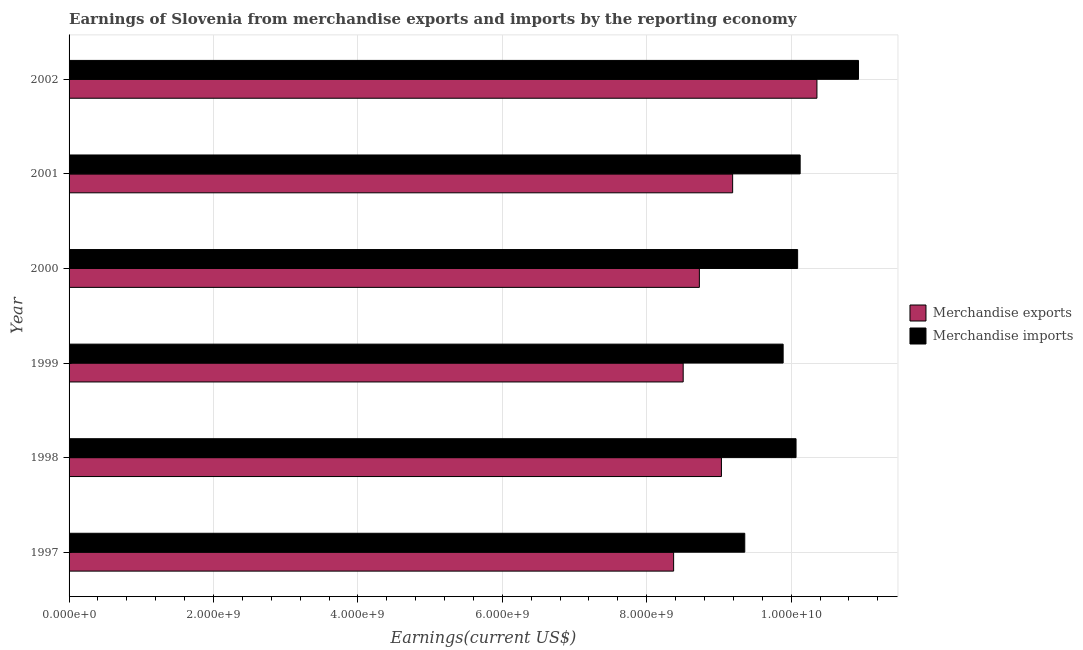How many groups of bars are there?
Give a very brief answer. 6. Are the number of bars per tick equal to the number of legend labels?
Offer a very short reply. Yes. How many bars are there on the 6th tick from the bottom?
Offer a very short reply. 2. In how many cases, is the number of bars for a given year not equal to the number of legend labels?
Keep it short and to the point. 0. What is the earnings from merchandise exports in 1997?
Ensure brevity in your answer.  8.37e+09. Across all years, what is the maximum earnings from merchandise imports?
Your answer should be compact. 1.09e+1. Across all years, what is the minimum earnings from merchandise imports?
Offer a terse response. 9.36e+09. What is the total earnings from merchandise imports in the graph?
Ensure brevity in your answer.  6.05e+1. What is the difference between the earnings from merchandise exports in 1999 and that in 2002?
Offer a very short reply. -1.85e+09. What is the difference between the earnings from merchandise imports in 2002 and the earnings from merchandise exports in 1997?
Offer a terse response. 2.56e+09. What is the average earnings from merchandise imports per year?
Your answer should be very brief. 1.01e+1. In the year 2002, what is the difference between the earnings from merchandise imports and earnings from merchandise exports?
Offer a very short reply. 5.75e+08. In how many years, is the earnings from merchandise imports greater than 1200000000 US$?
Your answer should be very brief. 6. What is the ratio of the earnings from merchandise imports in 2001 to that in 2002?
Offer a very short reply. 0.93. Is the earnings from merchandise exports in 1998 less than that in 2000?
Provide a short and direct response. No. Is the difference between the earnings from merchandise imports in 1997 and 1998 greater than the difference between the earnings from merchandise exports in 1997 and 1998?
Your answer should be compact. No. What is the difference between the highest and the second highest earnings from merchandise imports?
Make the answer very short. 8.08e+08. What is the difference between the highest and the lowest earnings from merchandise exports?
Give a very brief answer. 1.98e+09. Is the sum of the earnings from merchandise imports in 2001 and 2002 greater than the maximum earnings from merchandise exports across all years?
Ensure brevity in your answer.  Yes. What does the 1st bar from the bottom in 1998 represents?
Your answer should be compact. Merchandise exports. Are the values on the major ticks of X-axis written in scientific E-notation?
Your answer should be compact. Yes. Does the graph contain any zero values?
Ensure brevity in your answer.  No. Does the graph contain grids?
Offer a terse response. Yes. Where does the legend appear in the graph?
Your response must be concise. Center right. How many legend labels are there?
Keep it short and to the point. 2. How are the legend labels stacked?
Provide a short and direct response. Vertical. What is the title of the graph?
Your answer should be very brief. Earnings of Slovenia from merchandise exports and imports by the reporting economy. Does "Non-solid fuel" appear as one of the legend labels in the graph?
Ensure brevity in your answer.  No. What is the label or title of the X-axis?
Offer a terse response. Earnings(current US$). What is the Earnings(current US$) in Merchandise exports in 1997?
Give a very brief answer. 8.37e+09. What is the Earnings(current US$) in Merchandise imports in 1997?
Your answer should be compact. 9.36e+09. What is the Earnings(current US$) in Merchandise exports in 1998?
Your response must be concise. 9.03e+09. What is the Earnings(current US$) in Merchandise imports in 1998?
Your response must be concise. 1.01e+1. What is the Earnings(current US$) of Merchandise exports in 1999?
Your response must be concise. 8.50e+09. What is the Earnings(current US$) of Merchandise imports in 1999?
Provide a short and direct response. 9.89e+09. What is the Earnings(current US$) in Merchandise exports in 2000?
Give a very brief answer. 8.73e+09. What is the Earnings(current US$) in Merchandise imports in 2000?
Ensure brevity in your answer.  1.01e+1. What is the Earnings(current US$) in Merchandise exports in 2001?
Ensure brevity in your answer.  9.19e+09. What is the Earnings(current US$) of Merchandise imports in 2001?
Ensure brevity in your answer.  1.01e+1. What is the Earnings(current US$) in Merchandise exports in 2002?
Provide a succinct answer. 1.04e+1. What is the Earnings(current US$) of Merchandise imports in 2002?
Keep it short and to the point. 1.09e+1. Across all years, what is the maximum Earnings(current US$) of Merchandise exports?
Provide a short and direct response. 1.04e+1. Across all years, what is the maximum Earnings(current US$) in Merchandise imports?
Your answer should be very brief. 1.09e+1. Across all years, what is the minimum Earnings(current US$) in Merchandise exports?
Give a very brief answer. 8.37e+09. Across all years, what is the minimum Earnings(current US$) of Merchandise imports?
Your answer should be compact. 9.36e+09. What is the total Earnings(current US$) of Merchandise exports in the graph?
Your response must be concise. 5.42e+1. What is the total Earnings(current US$) of Merchandise imports in the graph?
Provide a short and direct response. 6.05e+1. What is the difference between the Earnings(current US$) of Merchandise exports in 1997 and that in 1998?
Provide a succinct answer. -6.62e+08. What is the difference between the Earnings(current US$) of Merchandise imports in 1997 and that in 1998?
Offer a very short reply. -7.10e+08. What is the difference between the Earnings(current US$) of Merchandise exports in 1997 and that in 1999?
Offer a terse response. -1.33e+08. What is the difference between the Earnings(current US$) of Merchandise imports in 1997 and that in 1999?
Ensure brevity in your answer.  -5.32e+08. What is the difference between the Earnings(current US$) in Merchandise exports in 1997 and that in 2000?
Offer a terse response. -3.57e+08. What is the difference between the Earnings(current US$) of Merchandise imports in 1997 and that in 2000?
Ensure brevity in your answer.  -7.32e+08. What is the difference between the Earnings(current US$) of Merchandise exports in 1997 and that in 2001?
Your response must be concise. -8.17e+08. What is the difference between the Earnings(current US$) in Merchandise imports in 1997 and that in 2001?
Your response must be concise. -7.67e+08. What is the difference between the Earnings(current US$) in Merchandise exports in 1997 and that in 2002?
Your answer should be very brief. -1.98e+09. What is the difference between the Earnings(current US$) of Merchandise imports in 1997 and that in 2002?
Provide a succinct answer. -1.57e+09. What is the difference between the Earnings(current US$) of Merchandise exports in 1998 and that in 1999?
Provide a succinct answer. 5.30e+08. What is the difference between the Earnings(current US$) in Merchandise imports in 1998 and that in 1999?
Your response must be concise. 1.79e+08. What is the difference between the Earnings(current US$) of Merchandise exports in 1998 and that in 2000?
Give a very brief answer. 3.06e+08. What is the difference between the Earnings(current US$) in Merchandise imports in 1998 and that in 2000?
Offer a terse response. -2.18e+07. What is the difference between the Earnings(current US$) of Merchandise exports in 1998 and that in 2001?
Offer a very short reply. -1.55e+08. What is the difference between the Earnings(current US$) of Merchandise imports in 1998 and that in 2001?
Provide a succinct answer. -5.69e+07. What is the difference between the Earnings(current US$) in Merchandise exports in 1998 and that in 2002?
Give a very brief answer. -1.32e+09. What is the difference between the Earnings(current US$) of Merchandise imports in 1998 and that in 2002?
Offer a very short reply. -8.65e+08. What is the difference between the Earnings(current US$) of Merchandise exports in 1999 and that in 2000?
Ensure brevity in your answer.  -2.24e+08. What is the difference between the Earnings(current US$) in Merchandise imports in 1999 and that in 2000?
Ensure brevity in your answer.  -2.00e+08. What is the difference between the Earnings(current US$) in Merchandise exports in 1999 and that in 2001?
Offer a very short reply. -6.85e+08. What is the difference between the Earnings(current US$) in Merchandise imports in 1999 and that in 2001?
Your response must be concise. -2.36e+08. What is the difference between the Earnings(current US$) in Merchandise exports in 1999 and that in 2002?
Keep it short and to the point. -1.85e+09. What is the difference between the Earnings(current US$) in Merchandise imports in 1999 and that in 2002?
Your answer should be very brief. -1.04e+09. What is the difference between the Earnings(current US$) in Merchandise exports in 2000 and that in 2001?
Ensure brevity in your answer.  -4.61e+08. What is the difference between the Earnings(current US$) in Merchandise imports in 2000 and that in 2001?
Keep it short and to the point. -3.51e+07. What is the difference between the Earnings(current US$) in Merchandise exports in 2000 and that in 2002?
Ensure brevity in your answer.  -1.63e+09. What is the difference between the Earnings(current US$) in Merchandise imports in 2000 and that in 2002?
Ensure brevity in your answer.  -8.43e+08. What is the difference between the Earnings(current US$) of Merchandise exports in 2001 and that in 2002?
Make the answer very short. -1.17e+09. What is the difference between the Earnings(current US$) of Merchandise imports in 2001 and that in 2002?
Give a very brief answer. -8.08e+08. What is the difference between the Earnings(current US$) of Merchandise exports in 1997 and the Earnings(current US$) of Merchandise imports in 1998?
Ensure brevity in your answer.  -1.70e+09. What is the difference between the Earnings(current US$) of Merchandise exports in 1997 and the Earnings(current US$) of Merchandise imports in 1999?
Your answer should be compact. -1.52e+09. What is the difference between the Earnings(current US$) in Merchandise exports in 1997 and the Earnings(current US$) in Merchandise imports in 2000?
Keep it short and to the point. -1.72e+09. What is the difference between the Earnings(current US$) in Merchandise exports in 1997 and the Earnings(current US$) in Merchandise imports in 2001?
Your answer should be very brief. -1.75e+09. What is the difference between the Earnings(current US$) of Merchandise exports in 1997 and the Earnings(current US$) of Merchandise imports in 2002?
Keep it short and to the point. -2.56e+09. What is the difference between the Earnings(current US$) of Merchandise exports in 1998 and the Earnings(current US$) of Merchandise imports in 1999?
Offer a very short reply. -8.55e+08. What is the difference between the Earnings(current US$) in Merchandise exports in 1998 and the Earnings(current US$) in Merchandise imports in 2000?
Keep it short and to the point. -1.06e+09. What is the difference between the Earnings(current US$) of Merchandise exports in 1998 and the Earnings(current US$) of Merchandise imports in 2001?
Keep it short and to the point. -1.09e+09. What is the difference between the Earnings(current US$) in Merchandise exports in 1998 and the Earnings(current US$) in Merchandise imports in 2002?
Offer a terse response. -1.90e+09. What is the difference between the Earnings(current US$) of Merchandise exports in 1999 and the Earnings(current US$) of Merchandise imports in 2000?
Offer a very short reply. -1.58e+09. What is the difference between the Earnings(current US$) in Merchandise exports in 1999 and the Earnings(current US$) in Merchandise imports in 2001?
Provide a succinct answer. -1.62e+09. What is the difference between the Earnings(current US$) in Merchandise exports in 1999 and the Earnings(current US$) in Merchandise imports in 2002?
Your response must be concise. -2.43e+09. What is the difference between the Earnings(current US$) of Merchandise exports in 2000 and the Earnings(current US$) of Merchandise imports in 2001?
Make the answer very short. -1.40e+09. What is the difference between the Earnings(current US$) of Merchandise exports in 2000 and the Earnings(current US$) of Merchandise imports in 2002?
Your answer should be very brief. -2.20e+09. What is the difference between the Earnings(current US$) of Merchandise exports in 2001 and the Earnings(current US$) of Merchandise imports in 2002?
Your answer should be compact. -1.74e+09. What is the average Earnings(current US$) in Merchandise exports per year?
Ensure brevity in your answer.  9.03e+09. What is the average Earnings(current US$) in Merchandise imports per year?
Provide a short and direct response. 1.01e+1. In the year 1997, what is the difference between the Earnings(current US$) of Merchandise exports and Earnings(current US$) of Merchandise imports?
Give a very brief answer. -9.85e+08. In the year 1998, what is the difference between the Earnings(current US$) of Merchandise exports and Earnings(current US$) of Merchandise imports?
Give a very brief answer. -1.03e+09. In the year 1999, what is the difference between the Earnings(current US$) of Merchandise exports and Earnings(current US$) of Merchandise imports?
Provide a succinct answer. -1.38e+09. In the year 2000, what is the difference between the Earnings(current US$) of Merchandise exports and Earnings(current US$) of Merchandise imports?
Your response must be concise. -1.36e+09. In the year 2001, what is the difference between the Earnings(current US$) of Merchandise exports and Earnings(current US$) of Merchandise imports?
Provide a short and direct response. -9.35e+08. In the year 2002, what is the difference between the Earnings(current US$) of Merchandise exports and Earnings(current US$) of Merchandise imports?
Give a very brief answer. -5.75e+08. What is the ratio of the Earnings(current US$) of Merchandise exports in 1997 to that in 1998?
Offer a terse response. 0.93. What is the ratio of the Earnings(current US$) in Merchandise imports in 1997 to that in 1998?
Make the answer very short. 0.93. What is the ratio of the Earnings(current US$) in Merchandise exports in 1997 to that in 1999?
Offer a terse response. 0.98. What is the ratio of the Earnings(current US$) in Merchandise imports in 1997 to that in 1999?
Offer a very short reply. 0.95. What is the ratio of the Earnings(current US$) of Merchandise exports in 1997 to that in 2000?
Make the answer very short. 0.96. What is the ratio of the Earnings(current US$) in Merchandise imports in 1997 to that in 2000?
Offer a terse response. 0.93. What is the ratio of the Earnings(current US$) in Merchandise exports in 1997 to that in 2001?
Offer a very short reply. 0.91. What is the ratio of the Earnings(current US$) in Merchandise imports in 1997 to that in 2001?
Ensure brevity in your answer.  0.92. What is the ratio of the Earnings(current US$) in Merchandise exports in 1997 to that in 2002?
Your answer should be very brief. 0.81. What is the ratio of the Earnings(current US$) in Merchandise imports in 1997 to that in 2002?
Ensure brevity in your answer.  0.86. What is the ratio of the Earnings(current US$) of Merchandise exports in 1998 to that in 1999?
Offer a very short reply. 1.06. What is the ratio of the Earnings(current US$) of Merchandise imports in 1998 to that in 1999?
Offer a very short reply. 1.02. What is the ratio of the Earnings(current US$) in Merchandise exports in 1998 to that in 2000?
Provide a short and direct response. 1.03. What is the ratio of the Earnings(current US$) of Merchandise imports in 1998 to that in 2000?
Keep it short and to the point. 1. What is the ratio of the Earnings(current US$) of Merchandise exports in 1998 to that in 2001?
Your answer should be compact. 0.98. What is the ratio of the Earnings(current US$) in Merchandise exports in 1998 to that in 2002?
Offer a terse response. 0.87. What is the ratio of the Earnings(current US$) of Merchandise imports in 1998 to that in 2002?
Your answer should be very brief. 0.92. What is the ratio of the Earnings(current US$) in Merchandise exports in 1999 to that in 2000?
Give a very brief answer. 0.97. What is the ratio of the Earnings(current US$) in Merchandise imports in 1999 to that in 2000?
Offer a very short reply. 0.98. What is the ratio of the Earnings(current US$) in Merchandise exports in 1999 to that in 2001?
Your answer should be very brief. 0.93. What is the ratio of the Earnings(current US$) in Merchandise imports in 1999 to that in 2001?
Provide a short and direct response. 0.98. What is the ratio of the Earnings(current US$) in Merchandise exports in 1999 to that in 2002?
Your answer should be very brief. 0.82. What is the ratio of the Earnings(current US$) of Merchandise imports in 1999 to that in 2002?
Your response must be concise. 0.9. What is the ratio of the Earnings(current US$) of Merchandise exports in 2000 to that in 2001?
Give a very brief answer. 0.95. What is the ratio of the Earnings(current US$) in Merchandise exports in 2000 to that in 2002?
Offer a terse response. 0.84. What is the ratio of the Earnings(current US$) in Merchandise imports in 2000 to that in 2002?
Your response must be concise. 0.92. What is the ratio of the Earnings(current US$) of Merchandise exports in 2001 to that in 2002?
Your answer should be compact. 0.89. What is the ratio of the Earnings(current US$) in Merchandise imports in 2001 to that in 2002?
Give a very brief answer. 0.93. What is the difference between the highest and the second highest Earnings(current US$) of Merchandise exports?
Keep it short and to the point. 1.17e+09. What is the difference between the highest and the second highest Earnings(current US$) of Merchandise imports?
Your answer should be very brief. 8.08e+08. What is the difference between the highest and the lowest Earnings(current US$) of Merchandise exports?
Offer a terse response. 1.98e+09. What is the difference between the highest and the lowest Earnings(current US$) in Merchandise imports?
Keep it short and to the point. 1.57e+09. 